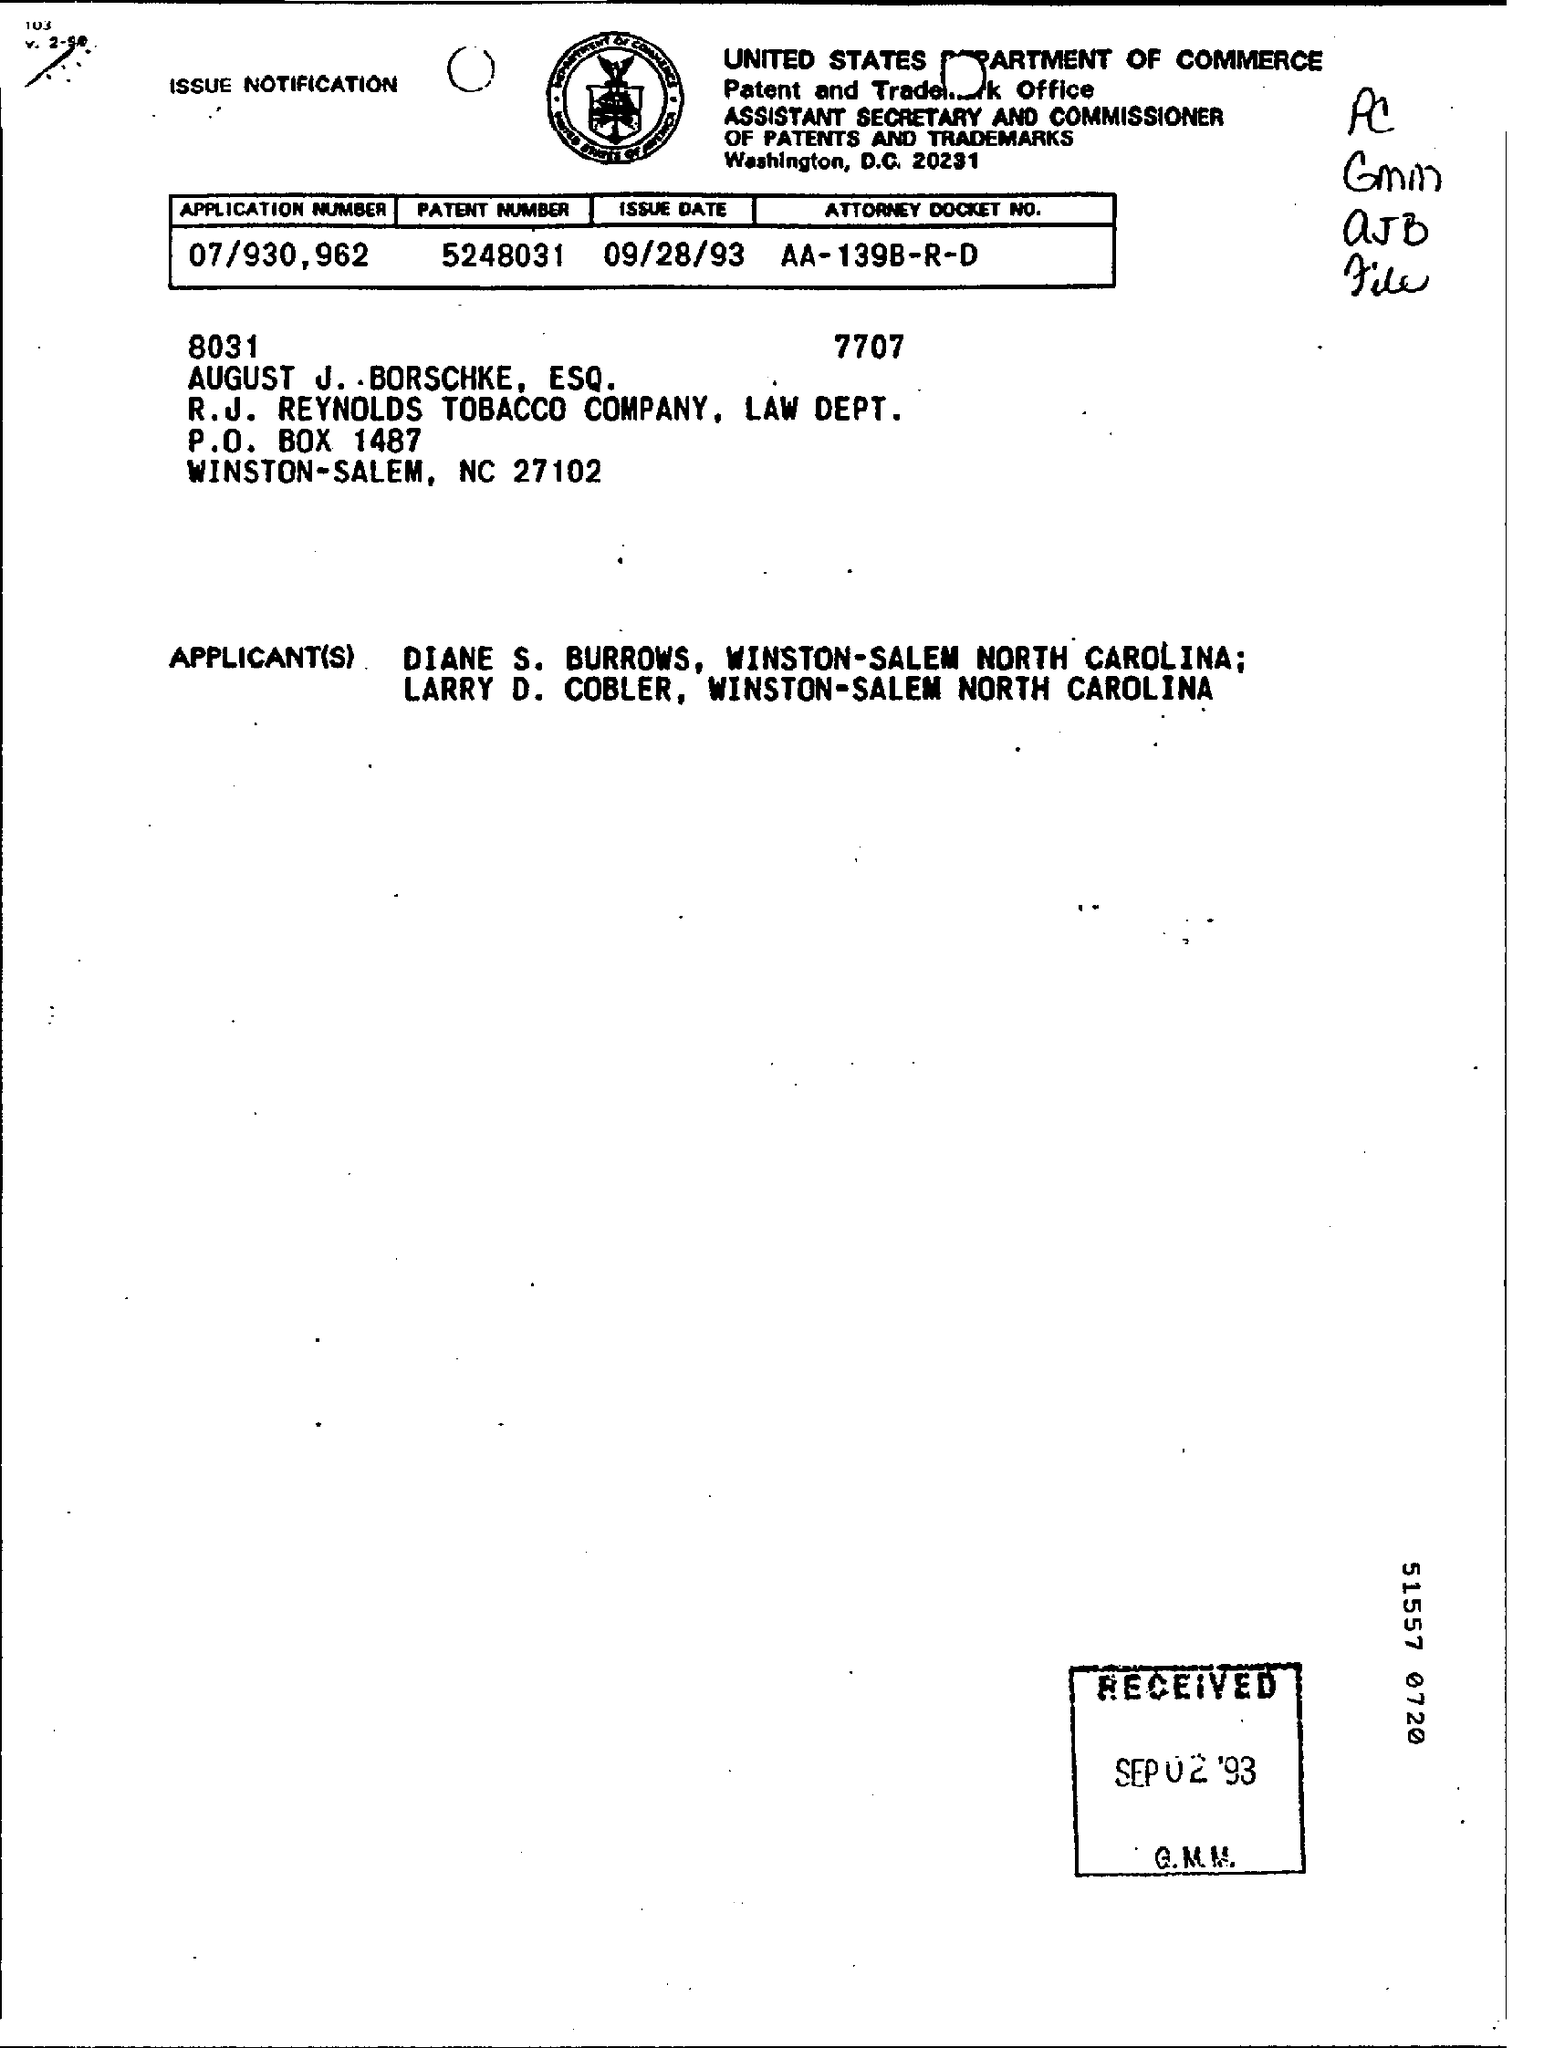List a handful of essential elements in this visual. The issue date is September 28, 1993. The application number is 07/930,962... The patent number is 5248031. 